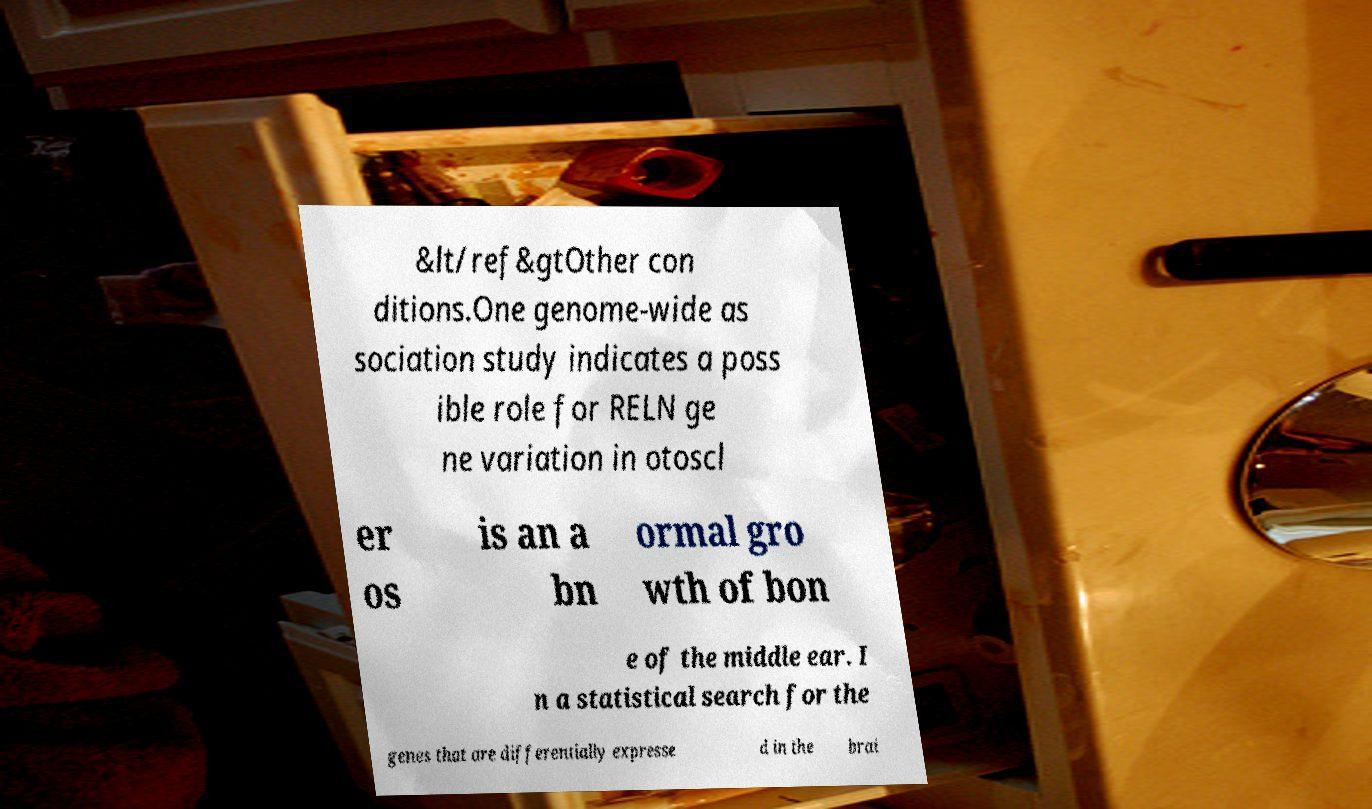For documentation purposes, I need the text within this image transcribed. Could you provide that? &lt/ref&gtOther con ditions.One genome-wide as sociation study indicates a poss ible role for RELN ge ne variation in otoscl er os is an a bn ormal gro wth of bon e of the middle ear. I n a statistical search for the genes that are differentially expresse d in the brai 